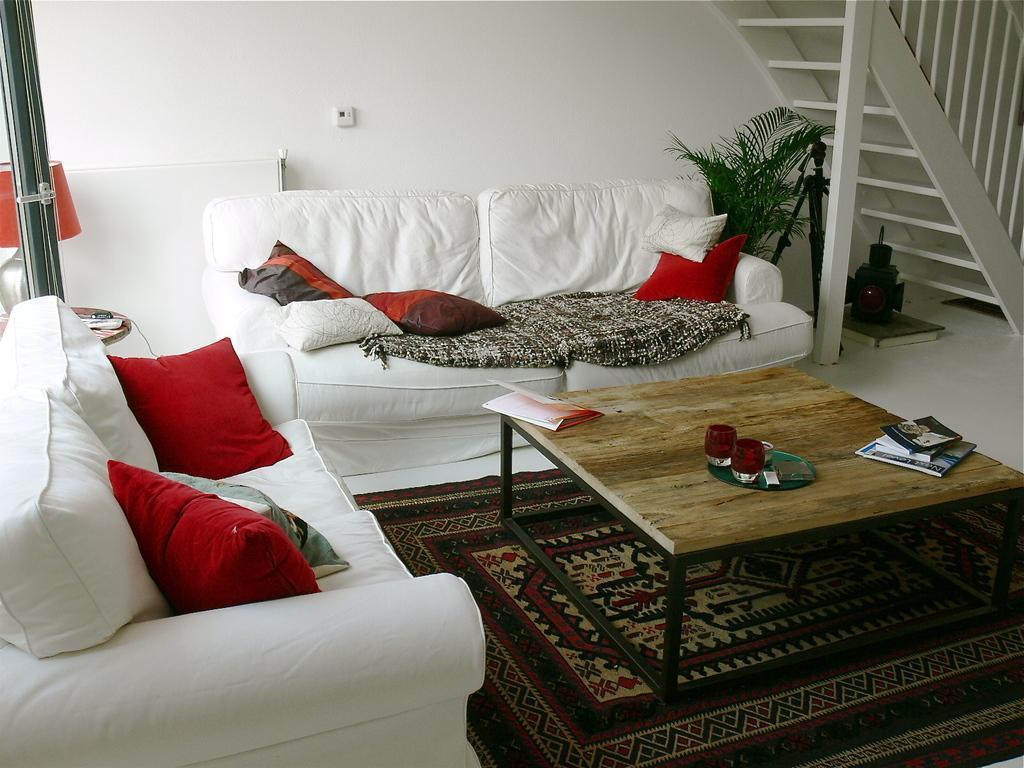Describe this image in one or two sentences. In this image there is a couch and a pillows and a cloth. On the table there is a lamp,glasses and books. A floor contain a floor mat,flower pot. On the background there are stairs. 